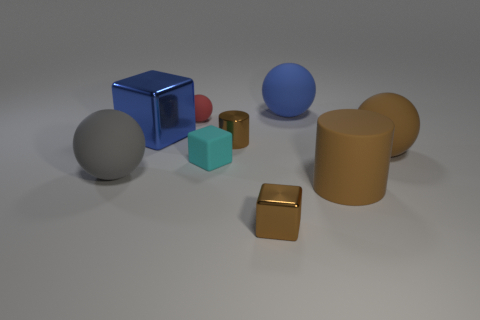Does the arrangement of objects suggest any particular theme? The arrangement of objects doesn't suggest a specific narrative theme, but rather seems to be a study in geometry and form. The variety of shapes—spheres, cylinders, cubes, and a cuboid—alongside the diversity of colors and materials, may evoke a sense of comparison and contrast, inviting the viewer to consider the interplay of these elements in space. 